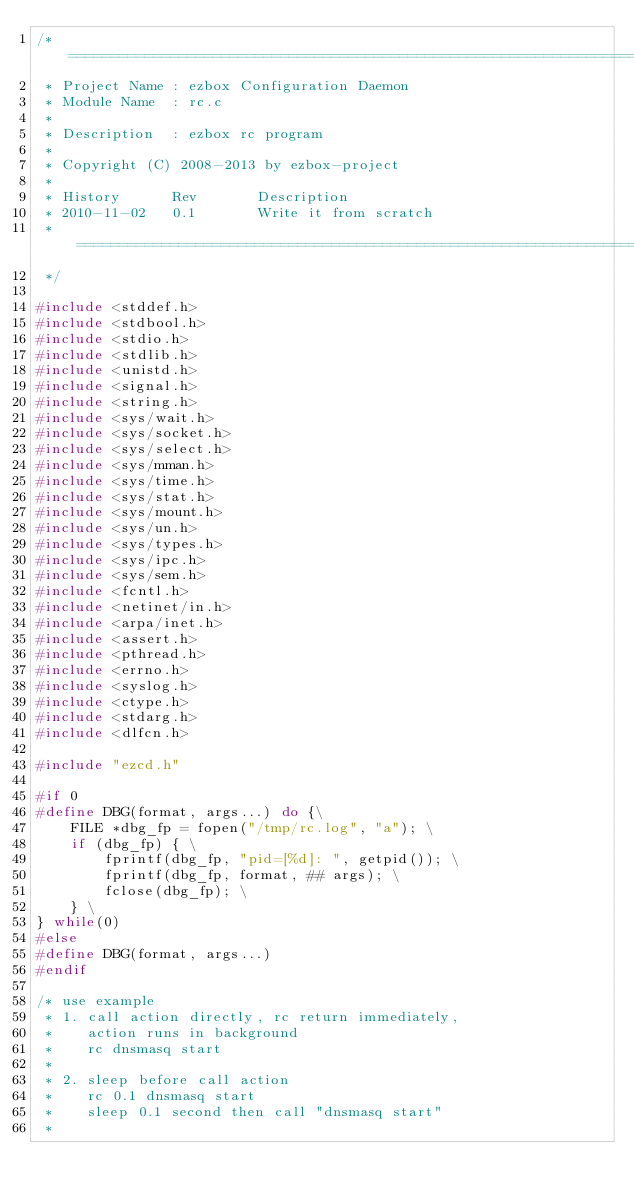Convert code to text. <code><loc_0><loc_0><loc_500><loc_500><_C_>/* ============================================================================
 * Project Name : ezbox Configuration Daemon
 * Module Name  : rc.c
 *
 * Description  : ezbox rc program
 *
 * Copyright (C) 2008-2013 by ezbox-project
 *
 * History      Rev       Description
 * 2010-11-02   0.1       Write it from scratch
 * ============================================================================
 */

#include <stddef.h>
#include <stdbool.h>
#include <stdio.h>
#include <stdlib.h>
#include <unistd.h>
#include <signal.h>
#include <string.h>
#include <sys/wait.h>
#include <sys/socket.h>
#include <sys/select.h>
#include <sys/mman.h>
#include <sys/time.h>
#include <sys/stat.h>
#include <sys/mount.h>
#include <sys/un.h>
#include <sys/types.h>
#include <sys/ipc.h>
#include <sys/sem.h>
#include <fcntl.h>
#include <netinet/in.h>
#include <arpa/inet.h>
#include <assert.h>
#include <pthread.h>
#include <errno.h>
#include <syslog.h>
#include <ctype.h>
#include <stdarg.h>
#include <dlfcn.h>

#include "ezcd.h"

#if 0
#define DBG(format, args...) do {\
	FILE *dbg_fp = fopen("/tmp/rc.log", "a"); \
	if (dbg_fp) { \
		fprintf(dbg_fp, "pid=[%d]: ", getpid()); \
		fprintf(dbg_fp, format, ## args); \
		fclose(dbg_fp); \
	} \
} while(0)
#else
#define DBG(format, args...)
#endif

/* use example
 * 1. call action directly, rc return immediately,
 *    action runs in background
 *    rc dnsmasq start
 *
 * 2. sleep before call action
 *    rc 0.1 dnsmasq start
 *    sleep 0.1 second then call "dnsmasq start"
 *</code> 